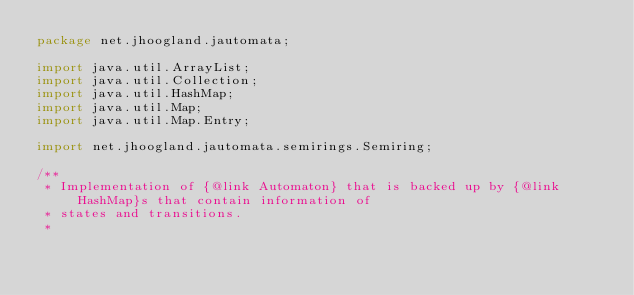<code> <loc_0><loc_0><loc_500><loc_500><_Java_>package net.jhoogland.jautomata;

import java.util.ArrayList;
import java.util.Collection;
import java.util.HashMap;
import java.util.Map;
import java.util.Map.Entry;

import net.jhoogland.jautomata.semirings.Semiring;

/**
 * Implementation of {@link Automaton} that is backed up by {@link HashMap}s that contain information of
 * states and transitions.
 * </code> 